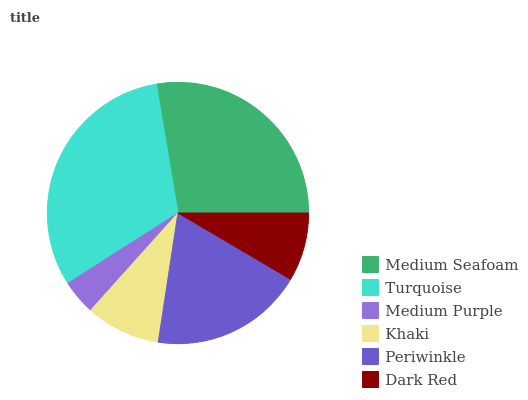Is Medium Purple the minimum?
Answer yes or no. Yes. Is Turquoise the maximum?
Answer yes or no. Yes. Is Turquoise the minimum?
Answer yes or no. No. Is Medium Purple the maximum?
Answer yes or no. No. Is Turquoise greater than Medium Purple?
Answer yes or no. Yes. Is Medium Purple less than Turquoise?
Answer yes or no. Yes. Is Medium Purple greater than Turquoise?
Answer yes or no. No. Is Turquoise less than Medium Purple?
Answer yes or no. No. Is Periwinkle the high median?
Answer yes or no. Yes. Is Khaki the low median?
Answer yes or no. Yes. Is Khaki the high median?
Answer yes or no. No. Is Periwinkle the low median?
Answer yes or no. No. 